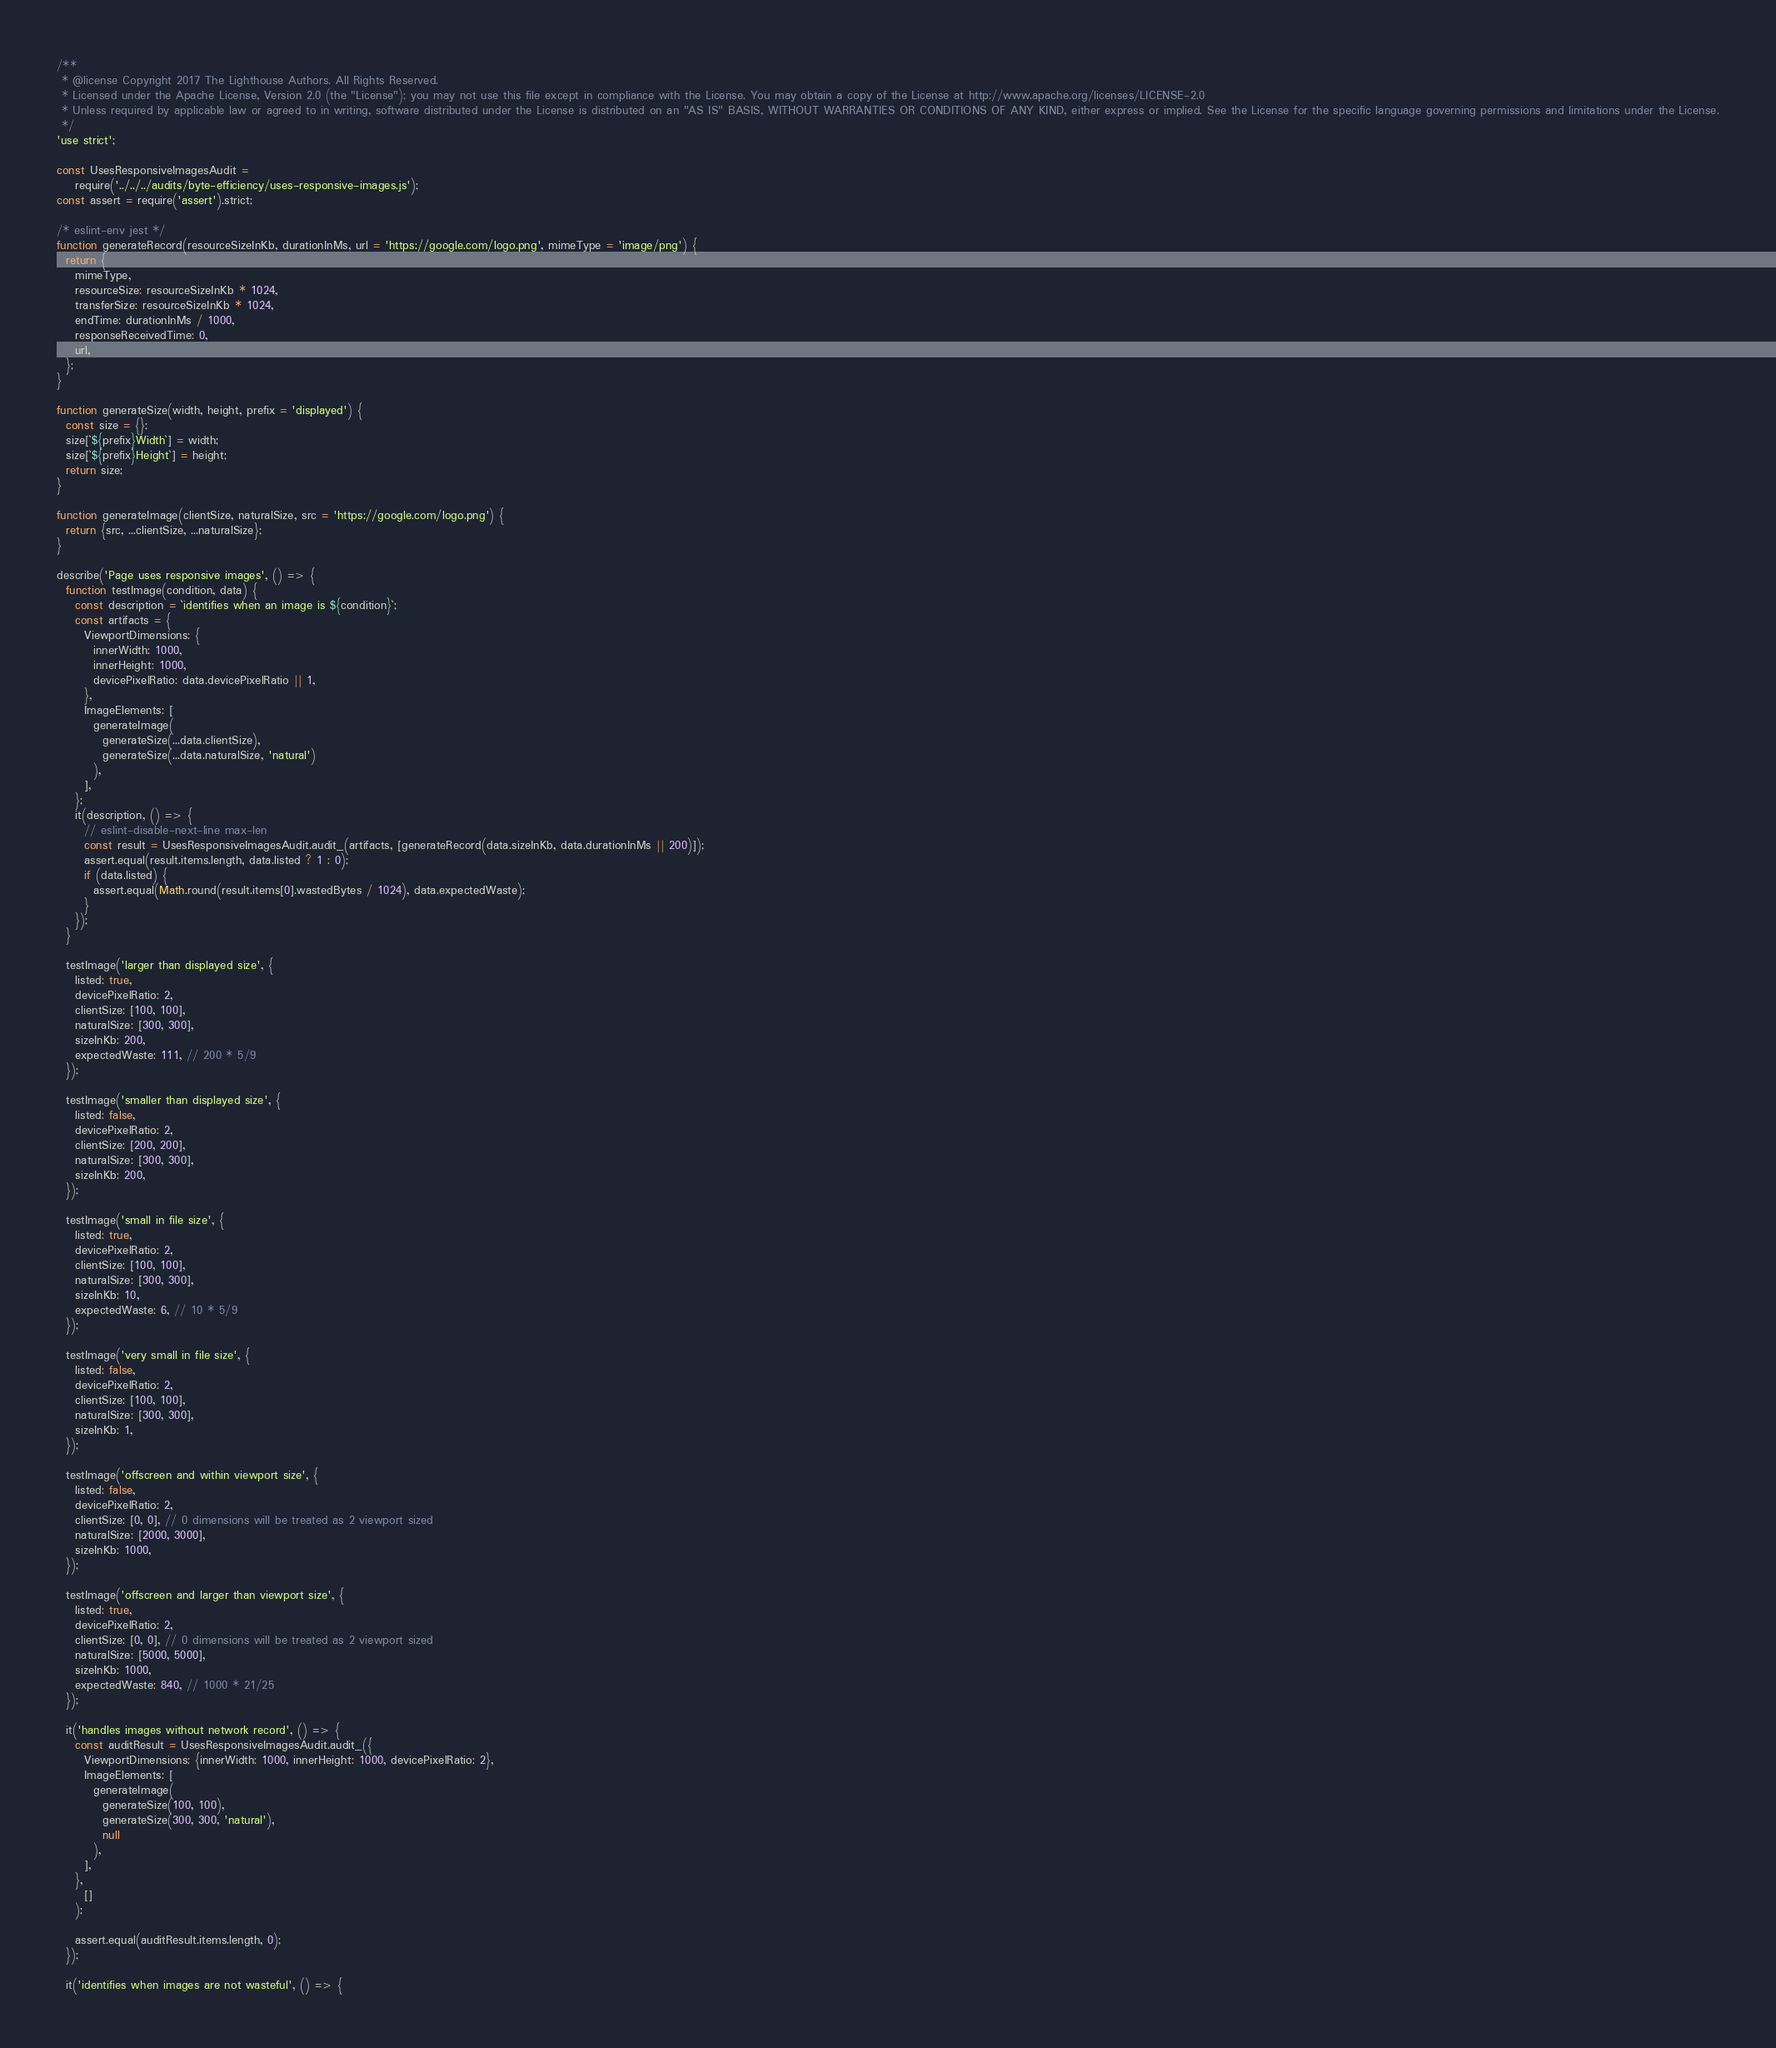<code> <loc_0><loc_0><loc_500><loc_500><_JavaScript_>/**
 * @license Copyright 2017 The Lighthouse Authors. All Rights Reserved.
 * Licensed under the Apache License, Version 2.0 (the "License"); you may not use this file except in compliance with the License. You may obtain a copy of the License at http://www.apache.org/licenses/LICENSE-2.0
 * Unless required by applicable law or agreed to in writing, software distributed under the License is distributed on an "AS IS" BASIS, WITHOUT WARRANTIES OR CONDITIONS OF ANY KIND, either express or implied. See the License for the specific language governing permissions and limitations under the License.
 */
'use strict';

const UsesResponsiveImagesAudit =
    require('../../../audits/byte-efficiency/uses-responsive-images.js');
const assert = require('assert').strict;

/* eslint-env jest */
function generateRecord(resourceSizeInKb, durationInMs, url = 'https://google.com/logo.png', mimeType = 'image/png') {
  return {
    mimeType,
    resourceSize: resourceSizeInKb * 1024,
    transferSize: resourceSizeInKb * 1024,
    endTime: durationInMs / 1000,
    responseReceivedTime: 0,
    url,
  };
}

function generateSize(width, height, prefix = 'displayed') {
  const size = {};
  size[`${prefix}Width`] = width;
  size[`${prefix}Height`] = height;
  return size;
}

function generateImage(clientSize, naturalSize, src = 'https://google.com/logo.png') {
  return {src, ...clientSize, ...naturalSize};
}

describe('Page uses responsive images', () => {
  function testImage(condition, data) {
    const description = `identifies when an image is ${condition}`;
    const artifacts = {
      ViewportDimensions: {
        innerWidth: 1000,
        innerHeight: 1000,
        devicePixelRatio: data.devicePixelRatio || 1,
      },
      ImageElements: [
        generateImage(
          generateSize(...data.clientSize),
          generateSize(...data.naturalSize, 'natural')
        ),
      ],
    };
    it(description, () => {
      // eslint-disable-next-line max-len
      const result = UsesResponsiveImagesAudit.audit_(artifacts, [generateRecord(data.sizeInKb, data.durationInMs || 200)]);
      assert.equal(result.items.length, data.listed ? 1 : 0);
      if (data.listed) {
        assert.equal(Math.round(result.items[0].wastedBytes / 1024), data.expectedWaste);
      }
    });
  }

  testImage('larger than displayed size', {
    listed: true,
    devicePixelRatio: 2,
    clientSize: [100, 100],
    naturalSize: [300, 300],
    sizeInKb: 200,
    expectedWaste: 111, // 200 * 5/9
  });

  testImage('smaller than displayed size', {
    listed: false,
    devicePixelRatio: 2,
    clientSize: [200, 200],
    naturalSize: [300, 300],
    sizeInKb: 200,
  });

  testImage('small in file size', {
    listed: true,
    devicePixelRatio: 2,
    clientSize: [100, 100],
    naturalSize: [300, 300],
    sizeInKb: 10,
    expectedWaste: 6, // 10 * 5/9
  });

  testImage('very small in file size', {
    listed: false,
    devicePixelRatio: 2,
    clientSize: [100, 100],
    naturalSize: [300, 300],
    sizeInKb: 1,
  });

  testImage('offscreen and within viewport size', {
    listed: false,
    devicePixelRatio: 2,
    clientSize: [0, 0], // 0 dimensions will be treated as 2 viewport sized
    naturalSize: [2000, 3000],
    sizeInKb: 1000,
  });

  testImage('offscreen and larger than viewport size', {
    listed: true,
    devicePixelRatio: 2,
    clientSize: [0, 0], // 0 dimensions will be treated as 2 viewport sized
    naturalSize: [5000, 5000],
    sizeInKb: 1000,
    expectedWaste: 840, // 1000 * 21/25
  });

  it('handles images without network record', () => {
    const auditResult = UsesResponsiveImagesAudit.audit_({
      ViewportDimensions: {innerWidth: 1000, innerHeight: 1000, devicePixelRatio: 2},
      ImageElements: [
        generateImage(
          generateSize(100, 100),
          generateSize(300, 300, 'natural'),
          null
        ),
      ],
    },
      []
    );

    assert.equal(auditResult.items.length, 0);
  });

  it('identifies when images are not wasteful', () => {</code> 